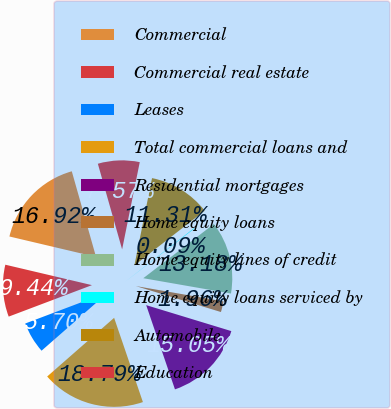Convert chart. <chart><loc_0><loc_0><loc_500><loc_500><pie_chart><fcel>Commercial<fcel>Commercial real estate<fcel>Leases<fcel>Total commercial loans and<fcel>Residential mortgages<fcel>Home equity loans<fcel>Home equity lines of credit<fcel>Home equity loans serviced by<fcel>Automobile<fcel>Education<nl><fcel>16.92%<fcel>9.44%<fcel>5.7%<fcel>18.79%<fcel>15.05%<fcel>1.96%<fcel>13.18%<fcel>0.09%<fcel>11.31%<fcel>7.57%<nl></chart> 